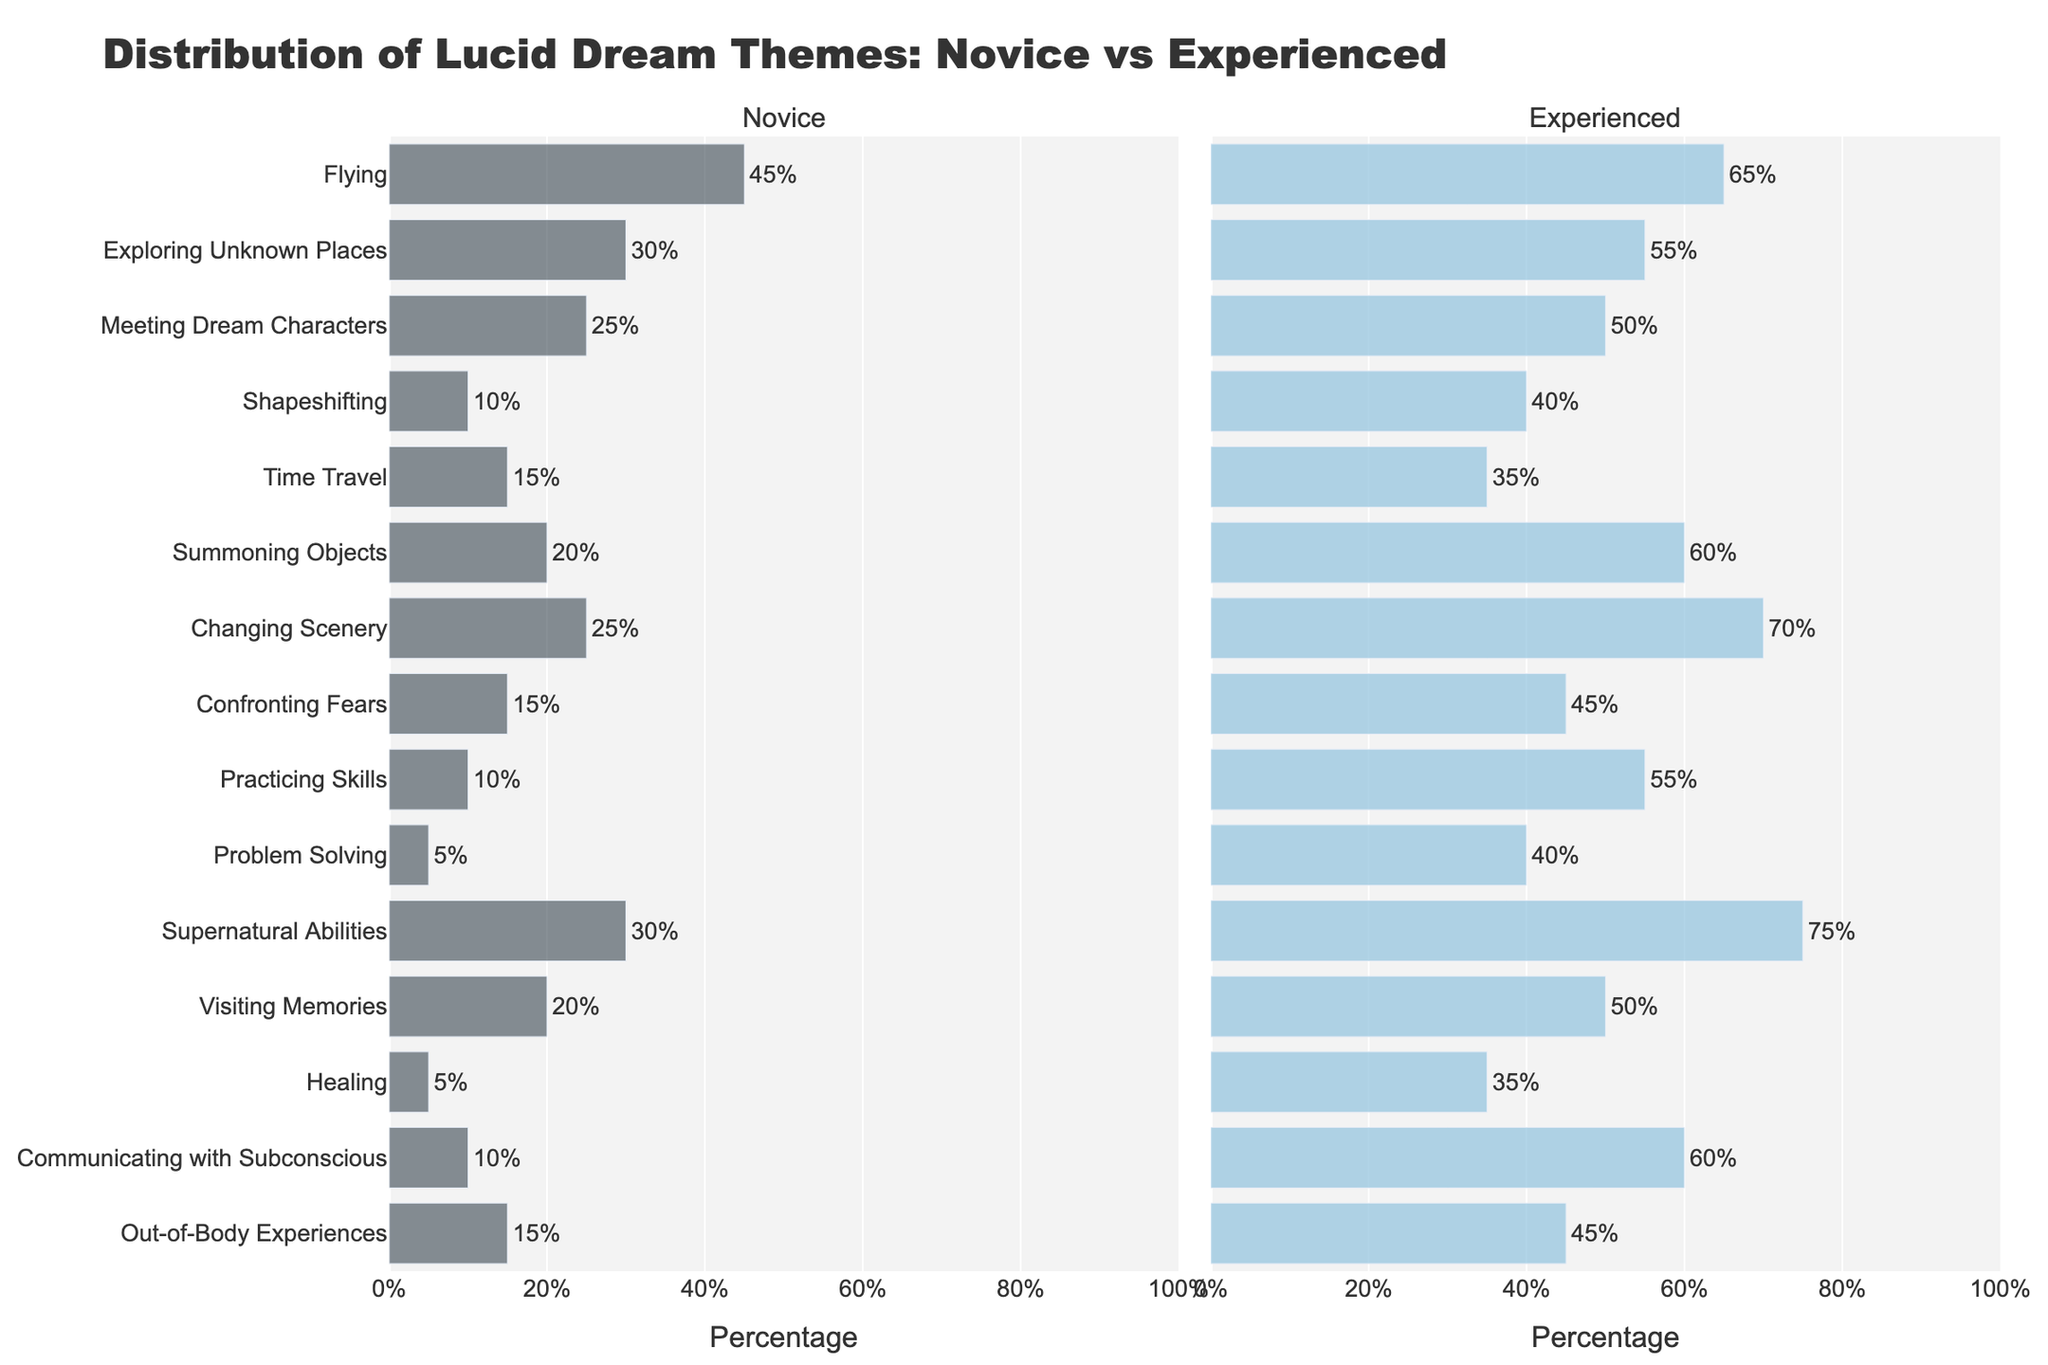Which theme shows the highest percentage difference between novice and experienced practitioners? To find the theme with the highest percentage difference, calculate the difference for each theme and compare. For "Shapeshifting," the difference is 40% - 10% = 30%. For "Summoning Objects," the difference is 60% - 20% = 40%. Continue this for each theme. "Supernatural Abilities" has a difference of 75% - 30% = 45%, which is the highest.
Answer: Supernatural Abilities Which themes have a higher percentage among novices than experienced practitioners, if any? Compare the percentages for each theme between novice and experienced practitioners. If the novice percentage is higher, the theme qualifies. In this data, there are no themes where novices have a higher percentage than experienced practitioners.
Answer: None For the theme "Confronting Fears," what is the percentage increase from novice to experienced practitioners? Find the percentage difference for "Confronting Fears" by subtracting the novice percentage from the experienced percentage: 45% - 15% = 30%.
Answer: 30% How many themes have over twice the percentage among experienced practitioners compared to novices? For each theme, check if the experienced percentage is more than double the novice percentage. "Shapeshifting" (40% > 2*10%), "Summoning Objects" (60% > 2*20%), "Changing Scenery" (70% > 2*25%), "Practicing Skills" (55% > 2*10%), "Problem Solving" (40% > 2*5%), "Supernatural Abilities" (75% > 2*30%), "Healing" (35% > 2*5%), "Communicating with Subconscious" (60% > 2*10%) are all qualifying themes. There are 8 such themes.
Answer: 8 Which theme is equally frequent among novices and experienced practitioners? Check for themes where the percentage for novices and experienced practitioners is the same. There are no themes with equal percentages in this data.
Answer: None 